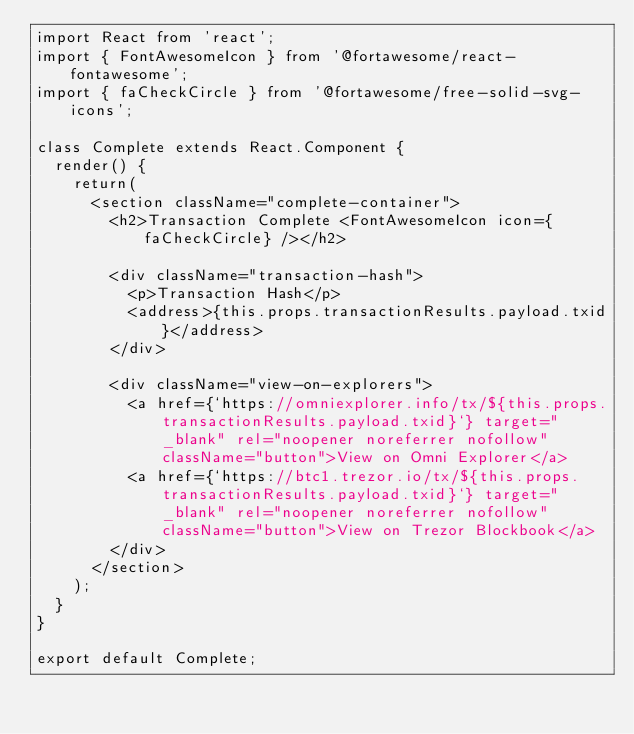Convert code to text. <code><loc_0><loc_0><loc_500><loc_500><_JavaScript_>import React from 'react';
import { FontAwesomeIcon } from '@fortawesome/react-fontawesome';
import { faCheckCircle } from '@fortawesome/free-solid-svg-icons';

class Complete extends React.Component {
  render() {
    return(
      <section className="complete-container">
        <h2>Transaction Complete <FontAwesomeIcon icon={faCheckCircle} /></h2>

        <div className="transaction-hash">
          <p>Transaction Hash</p>
          <address>{this.props.transactionResults.payload.txid}</address>
        </div>

        <div className="view-on-explorers">
          <a href={`https://omniexplorer.info/tx/${this.props.transactionResults.payload.txid}`} target="_blank" rel="noopener noreferrer nofollow" className="button">View on Omni Explorer</a>
          <a href={`https://btc1.trezor.io/tx/${this.props.transactionResults.payload.txid}`} target="_blank" rel="noopener noreferrer nofollow" className="button">View on Trezor Blockbook</a>
        </div>
      </section>
    );
  }
}

export default Complete;
</code> 